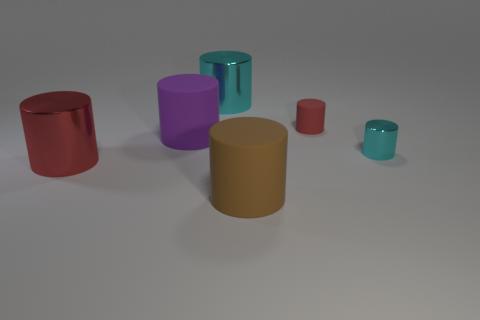Subtract 2 cylinders. How many cylinders are left? 4 Subtract all brown cylinders. How many cylinders are left? 5 Subtract all red matte cylinders. How many cylinders are left? 5 Subtract all brown cylinders. Subtract all gray spheres. How many cylinders are left? 5 Add 2 large metallic cylinders. How many objects exist? 8 Add 3 big green metal balls. How many big green metal balls exist? 3 Subtract 0 blue spheres. How many objects are left? 6 Subtract all big gray matte objects. Subtract all large matte things. How many objects are left? 4 Add 5 small rubber things. How many small rubber things are left? 6 